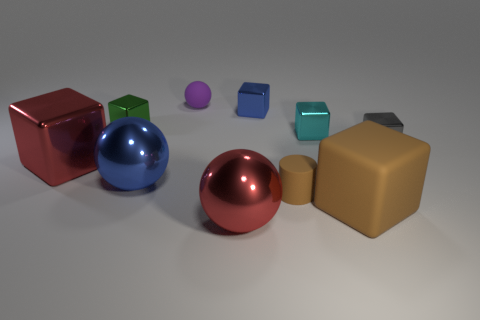Subtract all red cubes. How many cubes are left? 5 Subtract all big red metallic blocks. How many blocks are left? 5 Subtract all blue cubes. Subtract all green cylinders. How many cubes are left? 5 Subtract all cubes. How many objects are left? 4 Add 3 cyan metal cubes. How many cyan metal cubes exist? 4 Subtract 1 red blocks. How many objects are left? 9 Subtract all small gray cylinders. Subtract all blue metal objects. How many objects are left? 8 Add 5 large red metallic balls. How many large red metallic balls are left? 6 